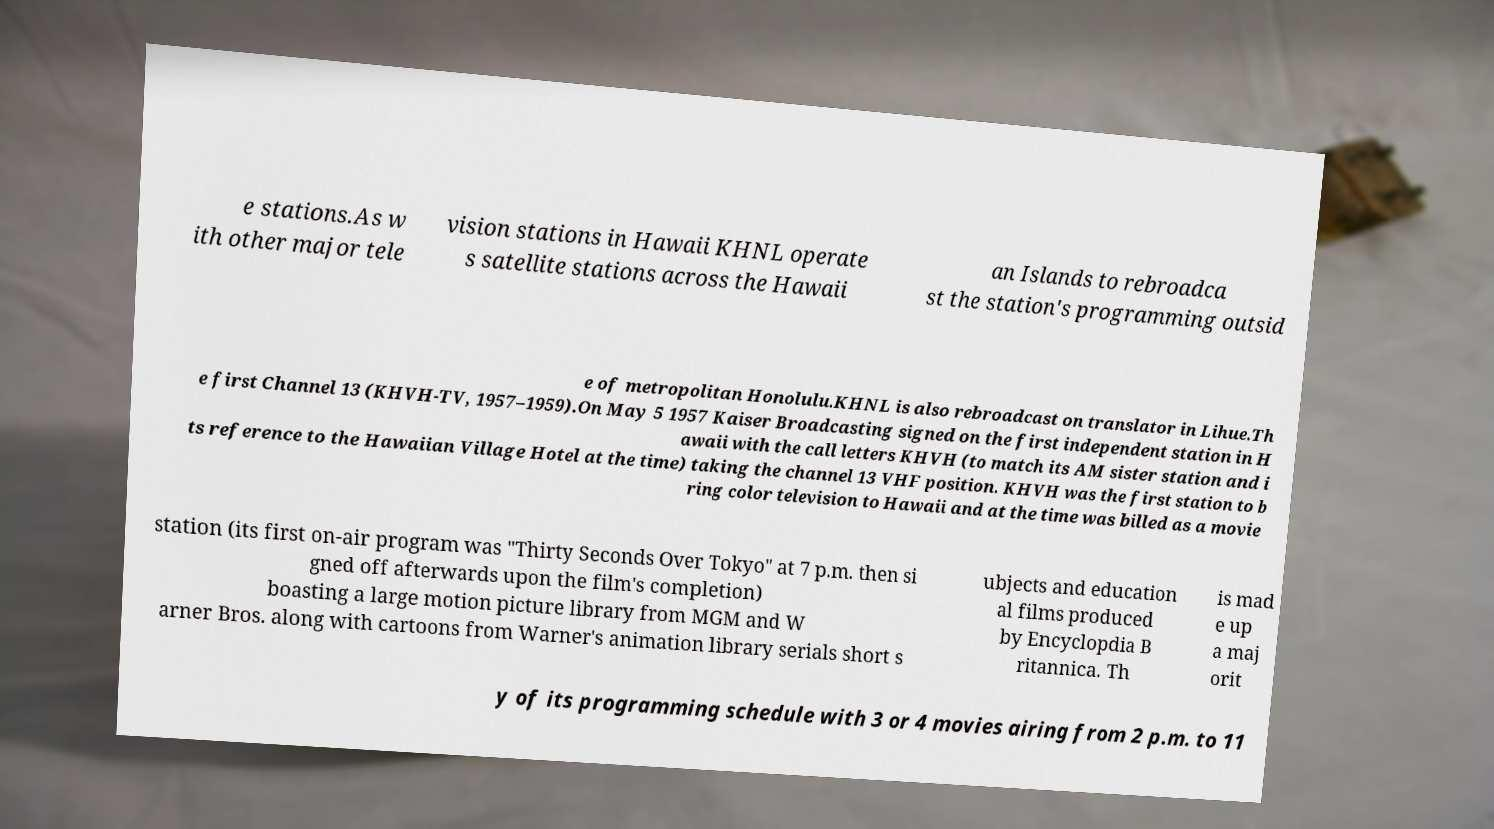What messages or text are displayed in this image? I need them in a readable, typed format. e stations.As w ith other major tele vision stations in Hawaii KHNL operate s satellite stations across the Hawaii an Islands to rebroadca st the station's programming outsid e of metropolitan Honolulu.KHNL is also rebroadcast on translator in Lihue.Th e first Channel 13 (KHVH-TV, 1957–1959).On May 5 1957 Kaiser Broadcasting signed on the first independent station in H awaii with the call letters KHVH (to match its AM sister station and i ts reference to the Hawaiian Village Hotel at the time) taking the channel 13 VHF position. KHVH was the first station to b ring color television to Hawaii and at the time was billed as a movie station (its first on-air program was "Thirty Seconds Over Tokyo" at 7 p.m. then si gned off afterwards upon the film's completion) boasting a large motion picture library from MGM and W arner Bros. along with cartoons from Warner's animation library serials short s ubjects and education al films produced by Encyclopdia B ritannica. Th is mad e up a maj orit y of its programming schedule with 3 or 4 movies airing from 2 p.m. to 11 